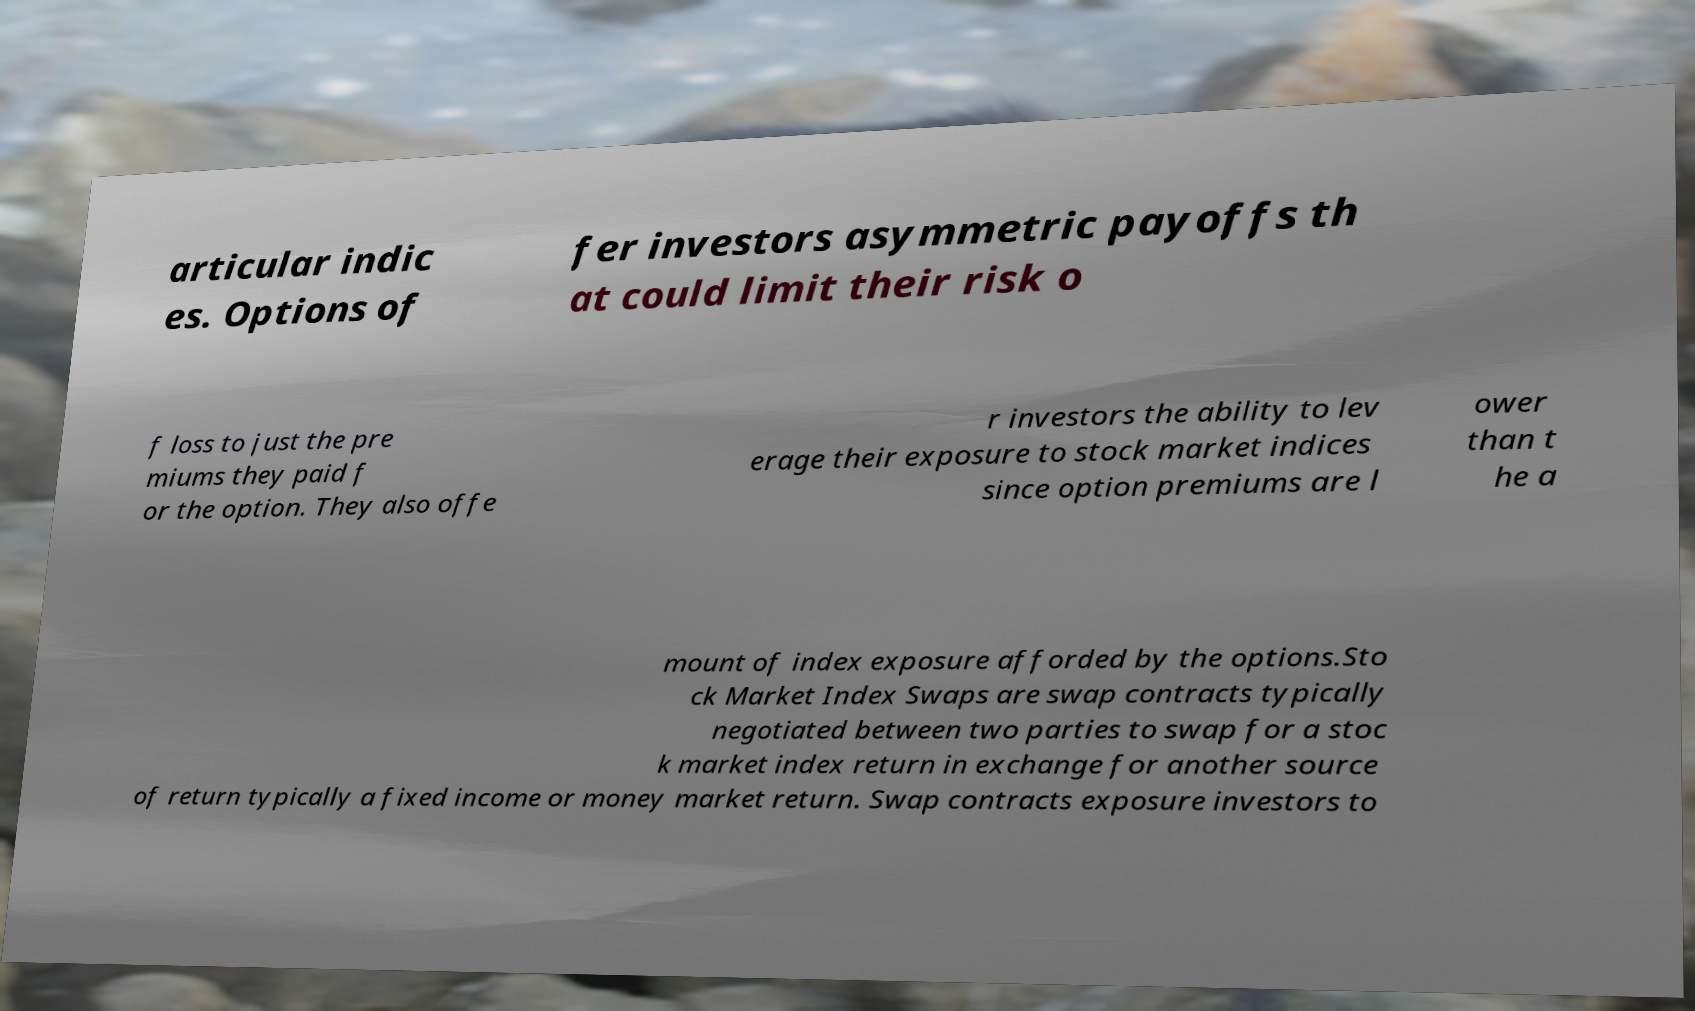For documentation purposes, I need the text within this image transcribed. Could you provide that? articular indic es. Options of fer investors asymmetric payoffs th at could limit their risk o f loss to just the pre miums they paid f or the option. They also offe r investors the ability to lev erage their exposure to stock market indices since option premiums are l ower than t he a mount of index exposure afforded by the options.Sto ck Market Index Swaps are swap contracts typically negotiated between two parties to swap for a stoc k market index return in exchange for another source of return typically a fixed income or money market return. Swap contracts exposure investors to 